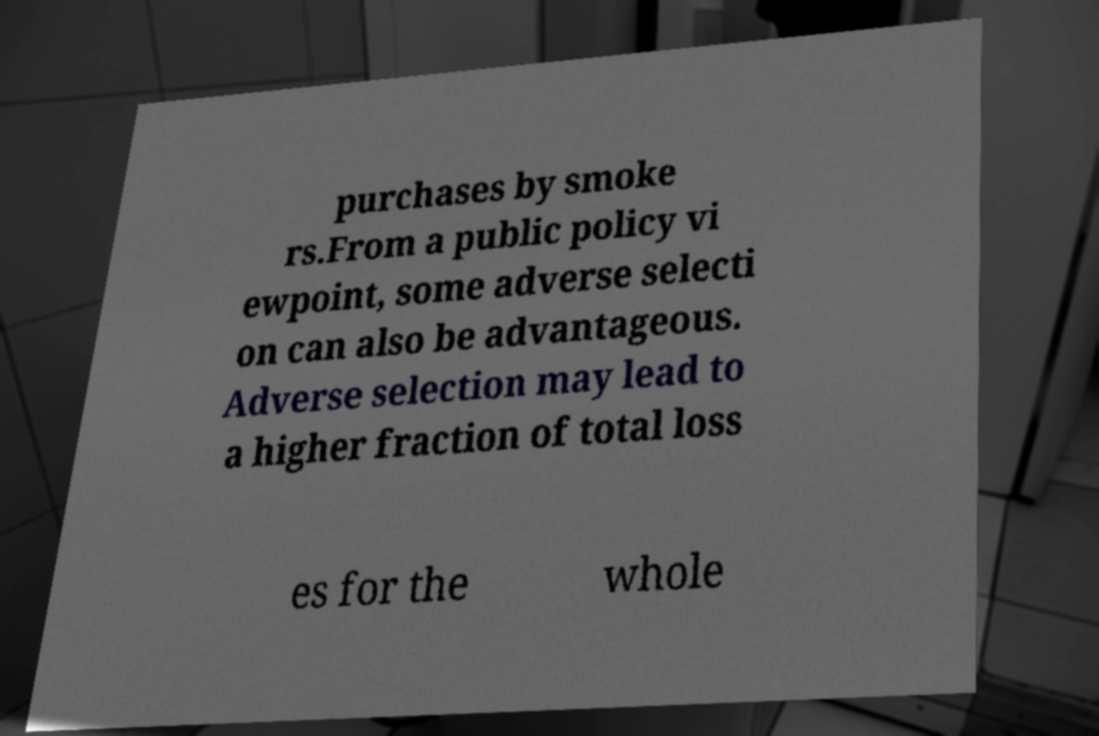I need the written content from this picture converted into text. Can you do that? purchases by smoke rs.From a public policy vi ewpoint, some adverse selecti on can also be advantageous. Adverse selection may lead to a higher fraction of total loss es for the whole 